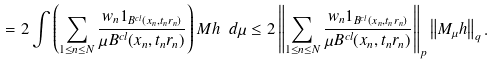<formula> <loc_0><loc_0><loc_500><loc_500>= 2 \int \left ( \sum _ { 1 \leq n \leq N } \frac { w _ { n } 1 _ { B ^ { c l } ( x _ { n } , t _ { n } r _ { n } ) } } { \mu B ^ { c l } ( x _ { n } , t _ { n } r _ { n } ) } \right ) M h \ d \mu \leq 2 \left \| \sum _ { 1 \leq n \leq N } \frac { w _ { n } 1 _ { B ^ { c l } ( x _ { n } , t _ { n } r _ { n } ) } } { \mu B ^ { c l } ( x _ { n } , t _ { n } r _ { n } ) } \right \| _ { p } \left \| M _ { \mu } h \right \| _ { q } .</formula> 